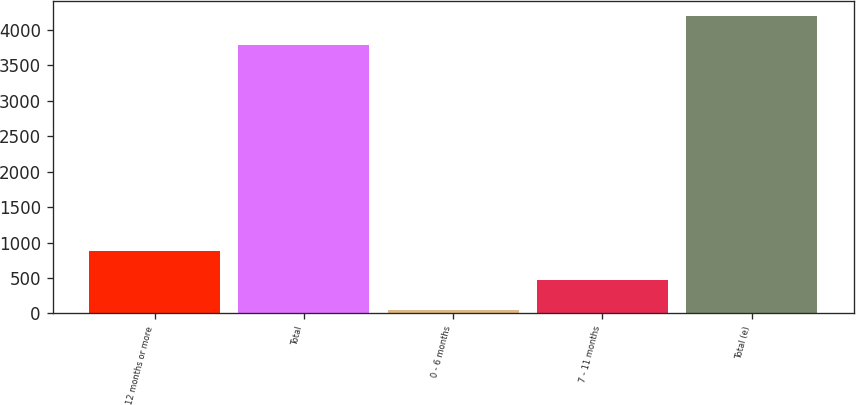Convert chart to OTSL. <chart><loc_0><loc_0><loc_500><loc_500><bar_chart><fcel>12 months or more<fcel>Total<fcel>0 - 6 months<fcel>7 - 11 months<fcel>Total (e)<nl><fcel>879.8<fcel>3784<fcel>52<fcel>465.9<fcel>4197.9<nl></chart> 